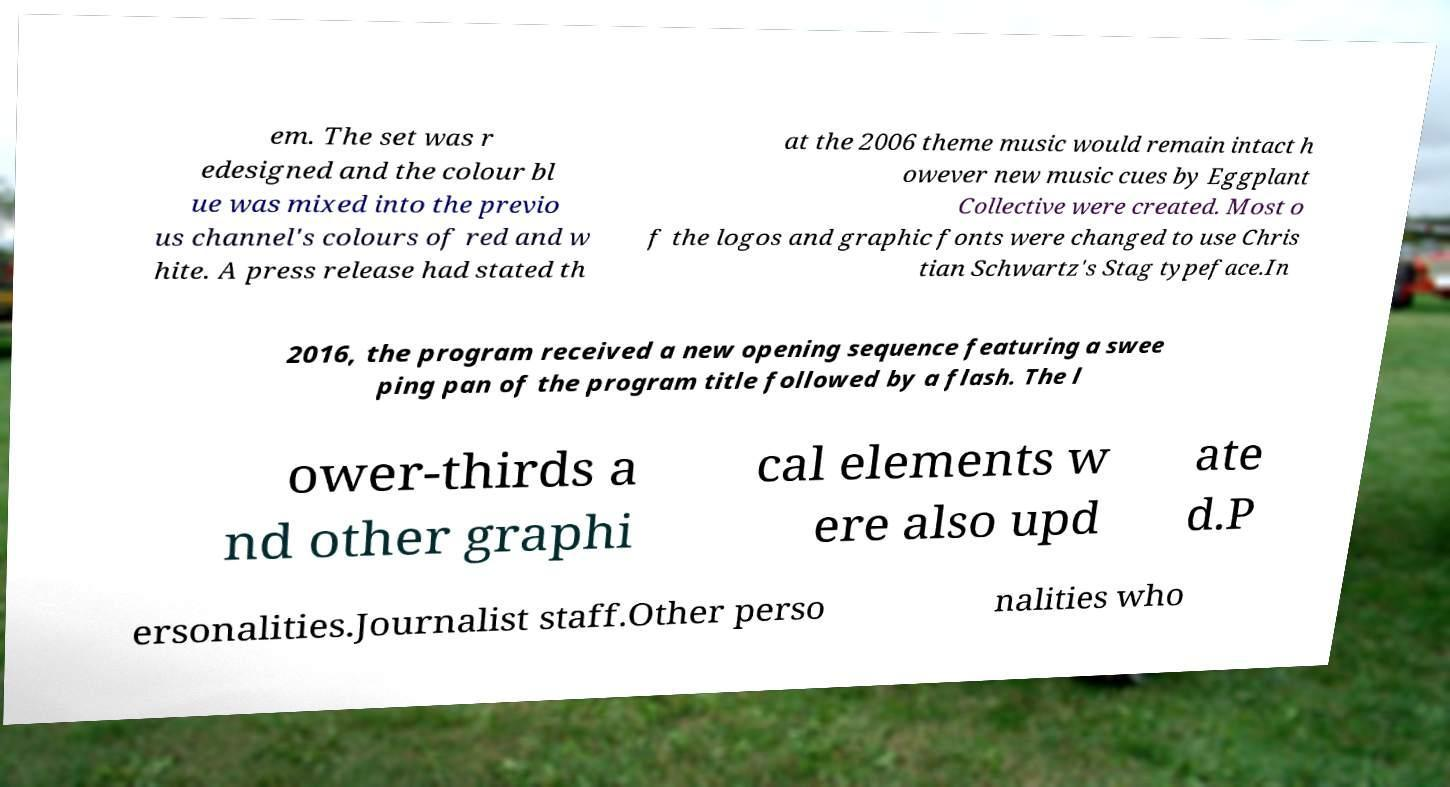Could you extract and type out the text from this image? em. The set was r edesigned and the colour bl ue was mixed into the previo us channel's colours of red and w hite. A press release had stated th at the 2006 theme music would remain intact h owever new music cues by Eggplant Collective were created. Most o f the logos and graphic fonts were changed to use Chris tian Schwartz's Stag typeface.In 2016, the program received a new opening sequence featuring a swee ping pan of the program title followed by a flash. The l ower-thirds a nd other graphi cal elements w ere also upd ate d.P ersonalities.Journalist staff.Other perso nalities who 